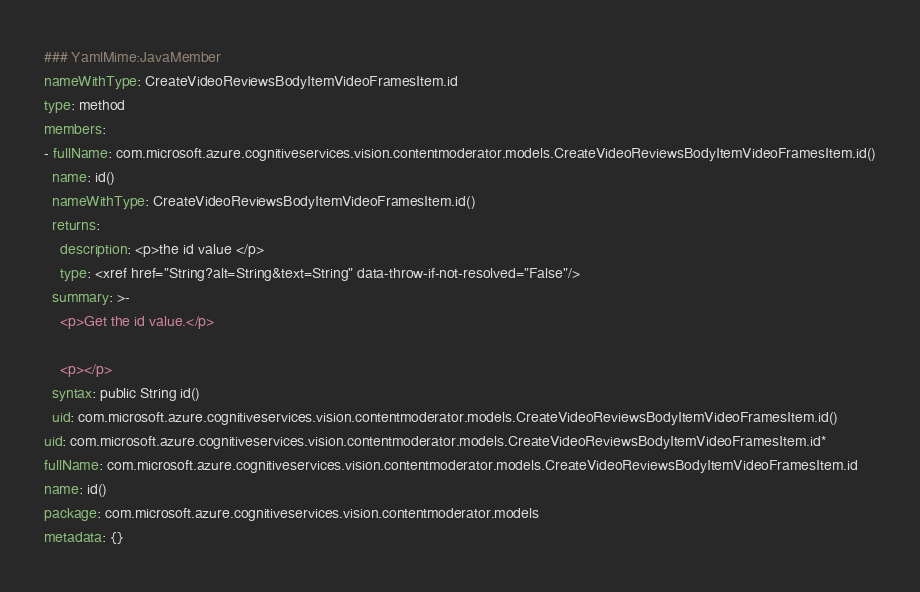<code> <loc_0><loc_0><loc_500><loc_500><_YAML_>### YamlMime:JavaMember
nameWithType: CreateVideoReviewsBodyItemVideoFramesItem.id
type: method
members:
- fullName: com.microsoft.azure.cognitiveservices.vision.contentmoderator.models.CreateVideoReviewsBodyItemVideoFramesItem.id()
  name: id()
  nameWithType: CreateVideoReviewsBodyItemVideoFramesItem.id()
  returns:
    description: <p>the id value </p>
    type: <xref href="String?alt=String&text=String" data-throw-if-not-resolved="False"/>
  summary: >-
    <p>Get the id value.</p>

    <p></p>
  syntax: public String id()
  uid: com.microsoft.azure.cognitiveservices.vision.contentmoderator.models.CreateVideoReviewsBodyItemVideoFramesItem.id()
uid: com.microsoft.azure.cognitiveservices.vision.contentmoderator.models.CreateVideoReviewsBodyItemVideoFramesItem.id*
fullName: com.microsoft.azure.cognitiveservices.vision.contentmoderator.models.CreateVideoReviewsBodyItemVideoFramesItem.id
name: id()
package: com.microsoft.azure.cognitiveservices.vision.contentmoderator.models
metadata: {}
</code> 